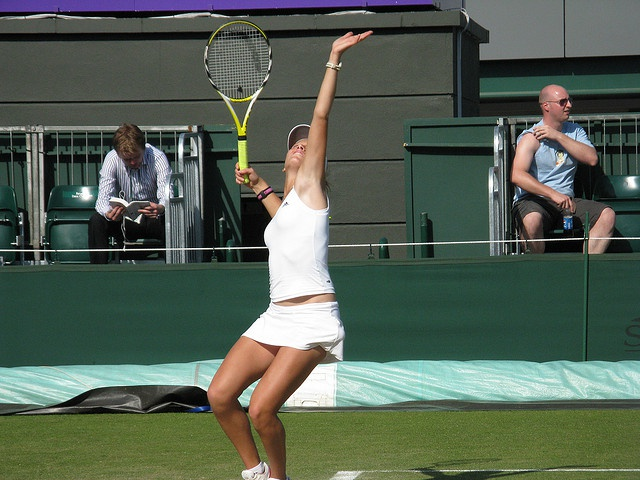Describe the objects in this image and their specific colors. I can see people in darkblue, white, salmon, and maroon tones, people in darkblue, black, tan, and gray tones, people in darkblue, black, gray, lightgray, and darkgray tones, tennis racket in darkblue, gray, darkgray, black, and darkgreen tones, and chair in darkblue, black, and teal tones in this image. 